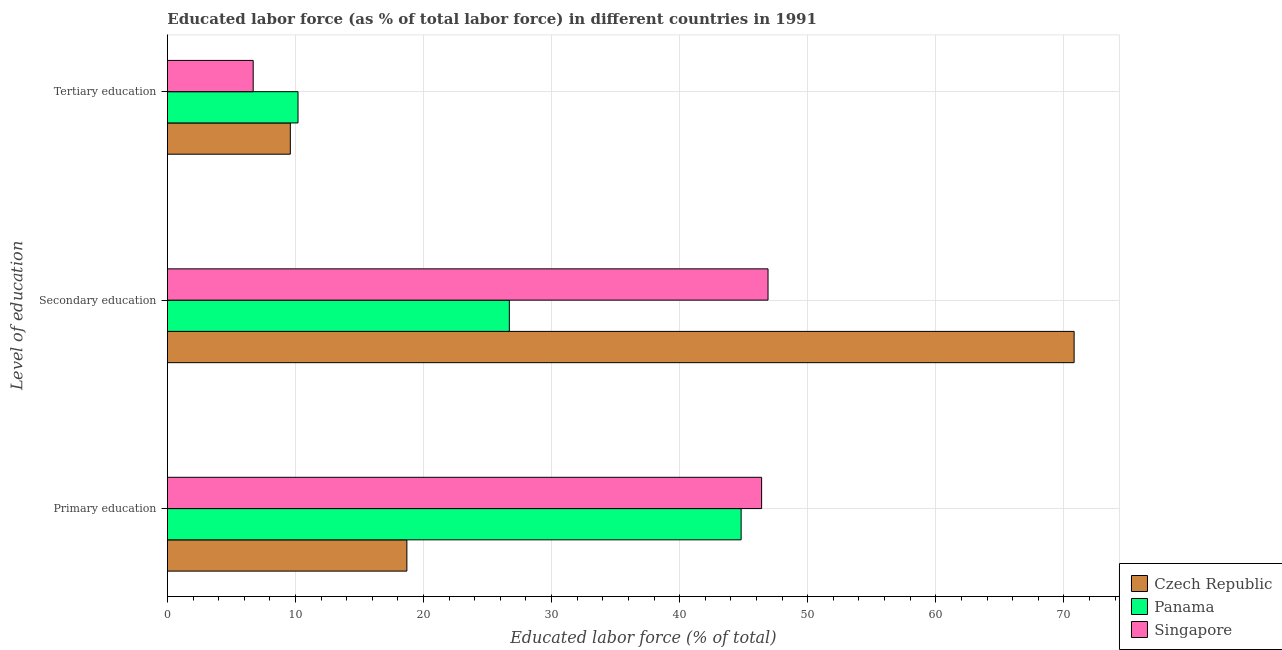How many bars are there on the 1st tick from the bottom?
Make the answer very short. 3. What is the percentage of labor force who received secondary education in Panama?
Keep it short and to the point. 26.7. Across all countries, what is the maximum percentage of labor force who received tertiary education?
Offer a terse response. 10.2. Across all countries, what is the minimum percentage of labor force who received primary education?
Provide a succinct answer. 18.7. In which country was the percentage of labor force who received primary education maximum?
Offer a terse response. Singapore. In which country was the percentage of labor force who received secondary education minimum?
Offer a very short reply. Panama. What is the total percentage of labor force who received secondary education in the graph?
Ensure brevity in your answer.  144.4. What is the difference between the percentage of labor force who received primary education in Czech Republic and that in Singapore?
Keep it short and to the point. -27.7. What is the difference between the percentage of labor force who received primary education in Singapore and the percentage of labor force who received tertiary education in Panama?
Your answer should be compact. 36.2. What is the average percentage of labor force who received tertiary education per country?
Make the answer very short. 8.83. What is the difference between the percentage of labor force who received secondary education and percentage of labor force who received tertiary education in Czech Republic?
Ensure brevity in your answer.  61.2. In how many countries, is the percentage of labor force who received secondary education greater than 32 %?
Your response must be concise. 2. What is the ratio of the percentage of labor force who received primary education in Singapore to that in Panama?
Provide a short and direct response. 1.04. Is the difference between the percentage of labor force who received secondary education in Czech Republic and Panama greater than the difference between the percentage of labor force who received primary education in Czech Republic and Panama?
Offer a very short reply. Yes. What is the difference between the highest and the second highest percentage of labor force who received tertiary education?
Your response must be concise. 0.6. What is the difference between the highest and the lowest percentage of labor force who received primary education?
Keep it short and to the point. 27.7. In how many countries, is the percentage of labor force who received secondary education greater than the average percentage of labor force who received secondary education taken over all countries?
Offer a very short reply. 1. Is the sum of the percentage of labor force who received secondary education in Singapore and Czech Republic greater than the maximum percentage of labor force who received tertiary education across all countries?
Your answer should be very brief. Yes. What does the 3rd bar from the top in Tertiary education represents?
Provide a short and direct response. Czech Republic. What does the 1st bar from the bottom in Secondary education represents?
Your answer should be very brief. Czech Republic. How many bars are there?
Provide a short and direct response. 9. How many countries are there in the graph?
Offer a terse response. 3. Are the values on the major ticks of X-axis written in scientific E-notation?
Your answer should be compact. No. Does the graph contain any zero values?
Provide a succinct answer. No. Does the graph contain grids?
Make the answer very short. Yes. What is the title of the graph?
Provide a succinct answer. Educated labor force (as % of total labor force) in different countries in 1991. What is the label or title of the X-axis?
Provide a succinct answer. Educated labor force (% of total). What is the label or title of the Y-axis?
Offer a very short reply. Level of education. What is the Educated labor force (% of total) of Czech Republic in Primary education?
Keep it short and to the point. 18.7. What is the Educated labor force (% of total) in Panama in Primary education?
Provide a succinct answer. 44.8. What is the Educated labor force (% of total) of Singapore in Primary education?
Your answer should be very brief. 46.4. What is the Educated labor force (% of total) of Czech Republic in Secondary education?
Your answer should be very brief. 70.8. What is the Educated labor force (% of total) in Panama in Secondary education?
Offer a very short reply. 26.7. What is the Educated labor force (% of total) in Singapore in Secondary education?
Your response must be concise. 46.9. What is the Educated labor force (% of total) of Czech Republic in Tertiary education?
Make the answer very short. 9.6. What is the Educated labor force (% of total) in Panama in Tertiary education?
Your answer should be compact. 10.2. What is the Educated labor force (% of total) in Singapore in Tertiary education?
Offer a very short reply. 6.7. Across all Level of education, what is the maximum Educated labor force (% of total) of Czech Republic?
Keep it short and to the point. 70.8. Across all Level of education, what is the maximum Educated labor force (% of total) of Panama?
Provide a succinct answer. 44.8. Across all Level of education, what is the maximum Educated labor force (% of total) in Singapore?
Offer a very short reply. 46.9. Across all Level of education, what is the minimum Educated labor force (% of total) of Czech Republic?
Keep it short and to the point. 9.6. Across all Level of education, what is the minimum Educated labor force (% of total) in Panama?
Your answer should be compact. 10.2. Across all Level of education, what is the minimum Educated labor force (% of total) of Singapore?
Offer a very short reply. 6.7. What is the total Educated labor force (% of total) in Czech Republic in the graph?
Your response must be concise. 99.1. What is the total Educated labor force (% of total) of Panama in the graph?
Your answer should be compact. 81.7. What is the difference between the Educated labor force (% of total) of Czech Republic in Primary education and that in Secondary education?
Offer a terse response. -52.1. What is the difference between the Educated labor force (% of total) of Singapore in Primary education and that in Secondary education?
Offer a terse response. -0.5. What is the difference between the Educated labor force (% of total) of Czech Republic in Primary education and that in Tertiary education?
Make the answer very short. 9.1. What is the difference between the Educated labor force (% of total) of Panama in Primary education and that in Tertiary education?
Your answer should be compact. 34.6. What is the difference between the Educated labor force (% of total) in Singapore in Primary education and that in Tertiary education?
Offer a very short reply. 39.7. What is the difference between the Educated labor force (% of total) in Czech Republic in Secondary education and that in Tertiary education?
Provide a succinct answer. 61.2. What is the difference between the Educated labor force (% of total) in Panama in Secondary education and that in Tertiary education?
Give a very brief answer. 16.5. What is the difference between the Educated labor force (% of total) of Singapore in Secondary education and that in Tertiary education?
Your answer should be very brief. 40.2. What is the difference between the Educated labor force (% of total) of Czech Republic in Primary education and the Educated labor force (% of total) of Singapore in Secondary education?
Give a very brief answer. -28.2. What is the difference between the Educated labor force (% of total) in Czech Republic in Primary education and the Educated labor force (% of total) in Panama in Tertiary education?
Your response must be concise. 8.5. What is the difference between the Educated labor force (% of total) in Panama in Primary education and the Educated labor force (% of total) in Singapore in Tertiary education?
Ensure brevity in your answer.  38.1. What is the difference between the Educated labor force (% of total) in Czech Republic in Secondary education and the Educated labor force (% of total) in Panama in Tertiary education?
Keep it short and to the point. 60.6. What is the difference between the Educated labor force (% of total) of Czech Republic in Secondary education and the Educated labor force (% of total) of Singapore in Tertiary education?
Offer a very short reply. 64.1. What is the average Educated labor force (% of total) in Czech Republic per Level of education?
Make the answer very short. 33.03. What is the average Educated labor force (% of total) of Panama per Level of education?
Ensure brevity in your answer.  27.23. What is the average Educated labor force (% of total) of Singapore per Level of education?
Offer a very short reply. 33.33. What is the difference between the Educated labor force (% of total) in Czech Republic and Educated labor force (% of total) in Panama in Primary education?
Your answer should be compact. -26.1. What is the difference between the Educated labor force (% of total) of Czech Republic and Educated labor force (% of total) of Singapore in Primary education?
Offer a terse response. -27.7. What is the difference between the Educated labor force (% of total) of Panama and Educated labor force (% of total) of Singapore in Primary education?
Give a very brief answer. -1.6. What is the difference between the Educated labor force (% of total) of Czech Republic and Educated labor force (% of total) of Panama in Secondary education?
Your answer should be compact. 44.1. What is the difference between the Educated labor force (% of total) in Czech Republic and Educated labor force (% of total) in Singapore in Secondary education?
Provide a short and direct response. 23.9. What is the difference between the Educated labor force (% of total) in Panama and Educated labor force (% of total) in Singapore in Secondary education?
Your answer should be compact. -20.2. What is the difference between the Educated labor force (% of total) of Czech Republic and Educated labor force (% of total) of Panama in Tertiary education?
Provide a short and direct response. -0.6. What is the difference between the Educated labor force (% of total) in Czech Republic and Educated labor force (% of total) in Singapore in Tertiary education?
Provide a succinct answer. 2.9. What is the difference between the Educated labor force (% of total) in Panama and Educated labor force (% of total) in Singapore in Tertiary education?
Ensure brevity in your answer.  3.5. What is the ratio of the Educated labor force (% of total) of Czech Republic in Primary education to that in Secondary education?
Keep it short and to the point. 0.26. What is the ratio of the Educated labor force (% of total) of Panama in Primary education to that in Secondary education?
Your answer should be compact. 1.68. What is the ratio of the Educated labor force (% of total) of Singapore in Primary education to that in Secondary education?
Your response must be concise. 0.99. What is the ratio of the Educated labor force (% of total) of Czech Republic in Primary education to that in Tertiary education?
Give a very brief answer. 1.95. What is the ratio of the Educated labor force (% of total) in Panama in Primary education to that in Tertiary education?
Make the answer very short. 4.39. What is the ratio of the Educated labor force (% of total) of Singapore in Primary education to that in Tertiary education?
Provide a short and direct response. 6.93. What is the ratio of the Educated labor force (% of total) in Czech Republic in Secondary education to that in Tertiary education?
Your response must be concise. 7.38. What is the ratio of the Educated labor force (% of total) of Panama in Secondary education to that in Tertiary education?
Your response must be concise. 2.62. What is the difference between the highest and the second highest Educated labor force (% of total) in Czech Republic?
Your answer should be very brief. 52.1. What is the difference between the highest and the second highest Educated labor force (% of total) of Panama?
Offer a terse response. 18.1. What is the difference between the highest and the lowest Educated labor force (% of total) of Czech Republic?
Your response must be concise. 61.2. What is the difference between the highest and the lowest Educated labor force (% of total) of Panama?
Your response must be concise. 34.6. What is the difference between the highest and the lowest Educated labor force (% of total) in Singapore?
Offer a very short reply. 40.2. 